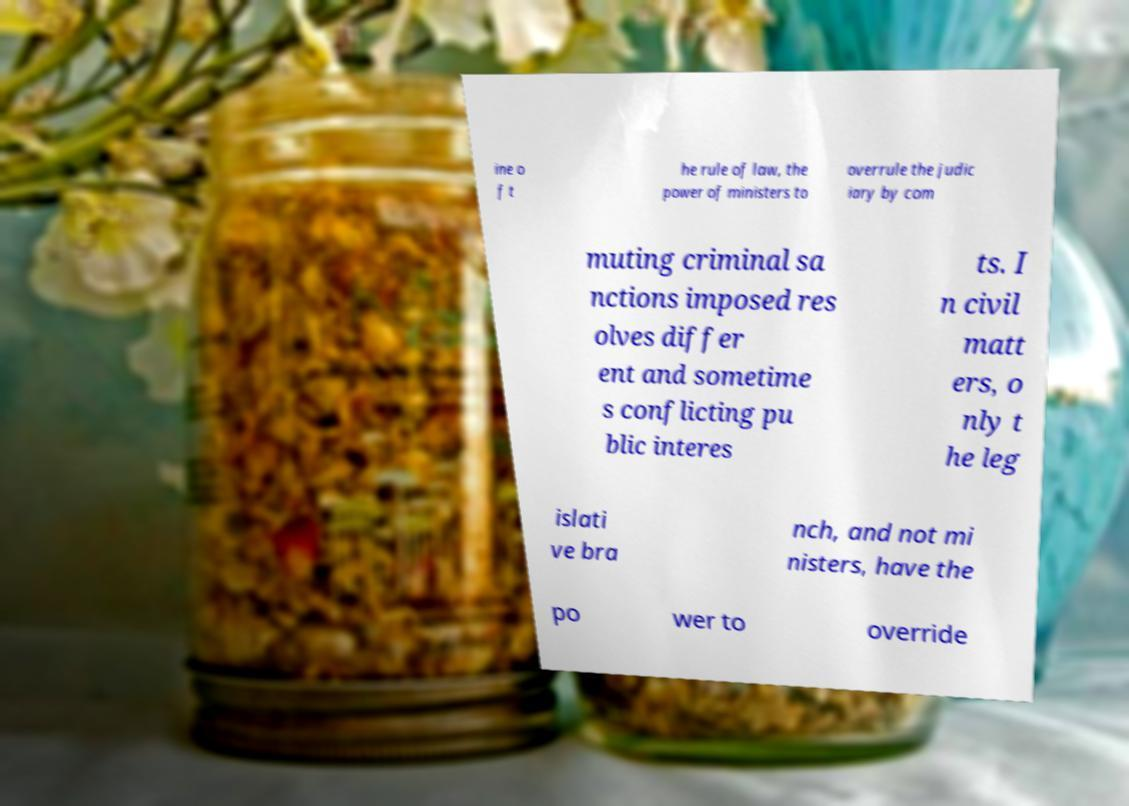What messages or text are displayed in this image? I need them in a readable, typed format. ine o f t he rule of law, the power of ministers to overrule the judic iary by com muting criminal sa nctions imposed res olves differ ent and sometime s conflicting pu blic interes ts. I n civil matt ers, o nly t he leg islati ve bra nch, and not mi nisters, have the po wer to override 